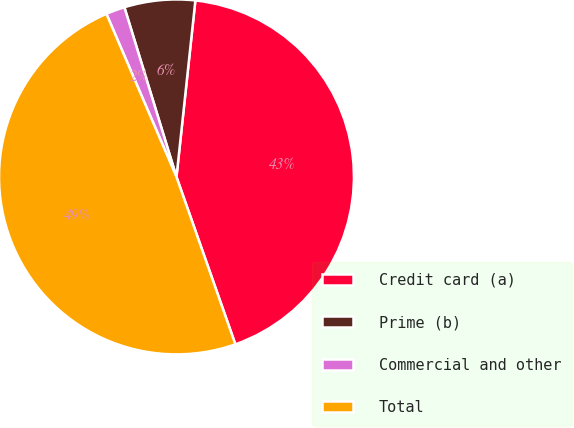Convert chart to OTSL. <chart><loc_0><loc_0><loc_500><loc_500><pie_chart><fcel>Credit card (a)<fcel>Prime (b)<fcel>Commercial and other<fcel>Total<nl><fcel>42.92%<fcel>6.44%<fcel>1.72%<fcel>48.93%<nl></chart> 